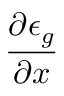Convert formula to latex. <formula><loc_0><loc_0><loc_500><loc_500>\frac { \partial \epsilon _ { g } } { \partial x }</formula> 